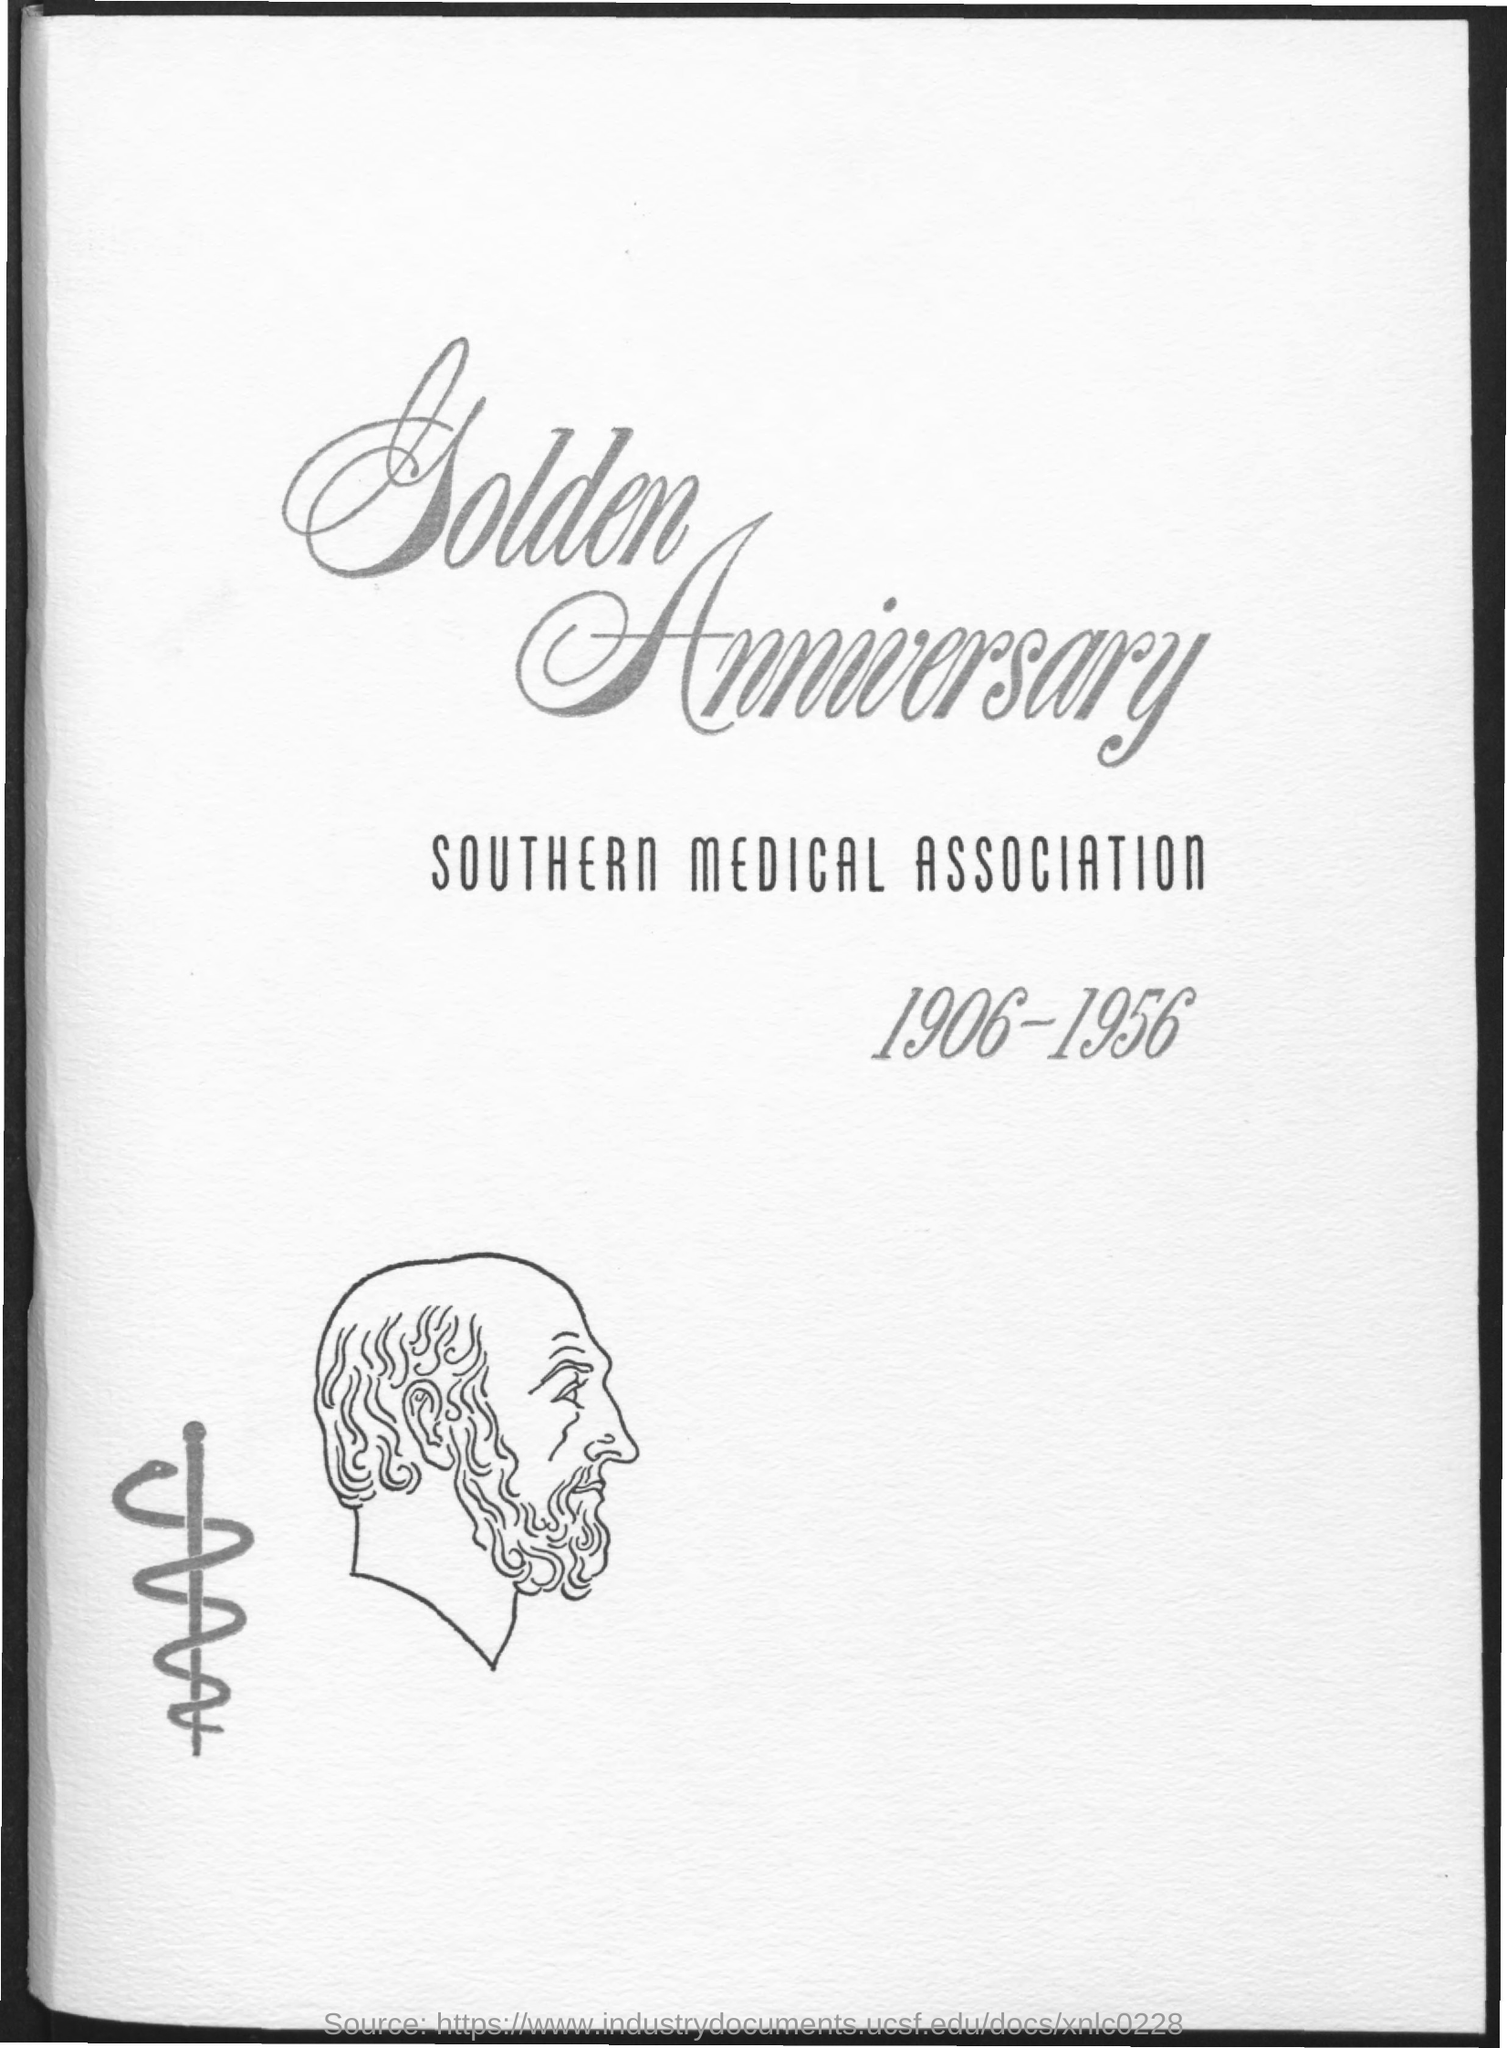Draw attention to some important aspects in this diagram. The first title in the document is "Golden Anniversary. The document mentions a range of years from 1906 to 1956. The second title in the document is "SOUTHERN MEDICAL ASSOCIATION..". 